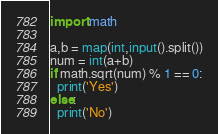Convert code to text. <code><loc_0><loc_0><loc_500><loc_500><_Python_>import math

a,b = map(int,input().split())
num = int(a+b)
if math.sqrt(num) % 1 == 0:
  print('Yes')
else:
  print('No')</code> 